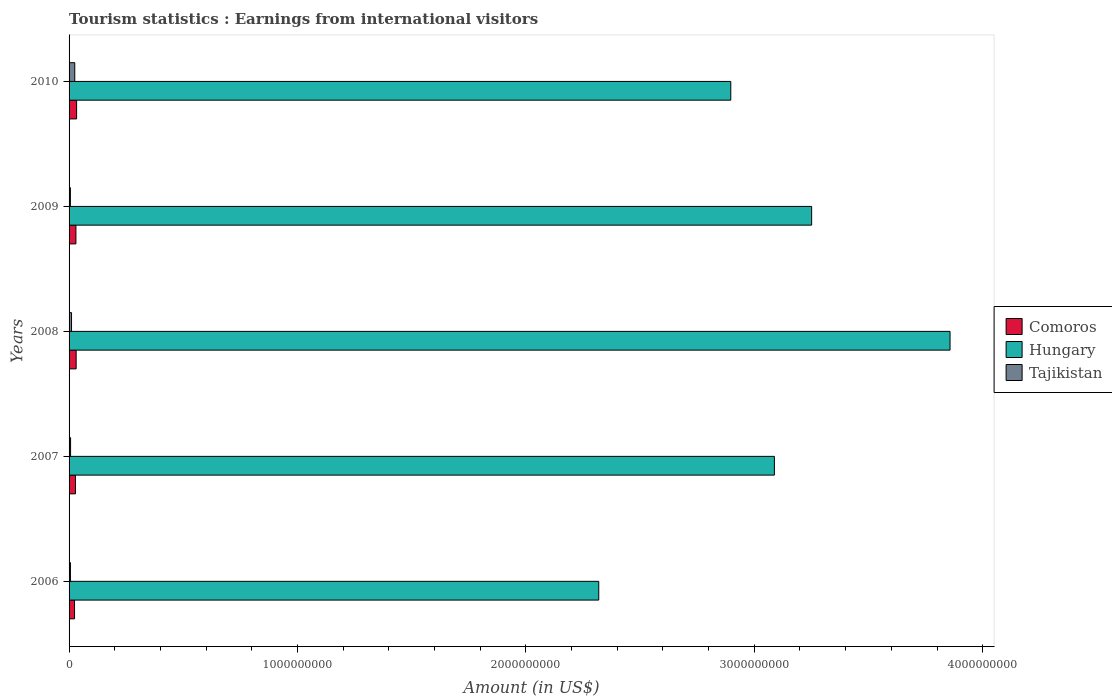How many groups of bars are there?
Your answer should be very brief. 5. Are the number of bars on each tick of the Y-axis equal?
Keep it short and to the point. Yes. How many bars are there on the 2nd tick from the top?
Make the answer very short. 3. How many bars are there on the 1st tick from the bottom?
Give a very brief answer. 3. What is the label of the 1st group of bars from the top?
Provide a succinct answer. 2010. What is the earnings from international visitors in Comoros in 2007?
Your response must be concise. 2.80e+07. Across all years, what is the maximum earnings from international visitors in Tajikistan?
Your answer should be very brief. 2.49e+07. Across all years, what is the minimum earnings from international visitors in Hungary?
Provide a succinct answer. 2.32e+09. In which year was the earnings from international visitors in Tajikistan maximum?
Offer a terse response. 2010. In which year was the earnings from international visitors in Tajikistan minimum?
Your answer should be very brief. 2009. What is the total earnings from international visitors in Hungary in the graph?
Keep it short and to the point. 1.54e+1. What is the difference between the earnings from international visitors in Hungary in 2009 and the earnings from international visitors in Tajikistan in 2007?
Your response must be concise. 3.24e+09. What is the average earnings from international visitors in Hungary per year?
Your response must be concise. 3.08e+09. In the year 2007, what is the difference between the earnings from international visitors in Comoros and earnings from international visitors in Hungary?
Offer a terse response. -3.06e+09. What is the ratio of the earnings from international visitors in Tajikistan in 2007 to that in 2008?
Ensure brevity in your answer.  0.61. Is the earnings from international visitors in Comoros in 2009 less than that in 2010?
Give a very brief answer. Yes. Is the difference between the earnings from international visitors in Comoros in 2008 and 2010 greater than the difference between the earnings from international visitors in Hungary in 2008 and 2010?
Ensure brevity in your answer.  No. What is the difference between the highest and the second highest earnings from international visitors in Comoros?
Your answer should be compact. 2.00e+06. What is the difference between the highest and the lowest earnings from international visitors in Hungary?
Give a very brief answer. 1.54e+09. What does the 3rd bar from the top in 2008 represents?
Offer a terse response. Comoros. What does the 2nd bar from the bottom in 2006 represents?
Provide a succinct answer. Hungary. Is it the case that in every year, the sum of the earnings from international visitors in Comoros and earnings from international visitors in Hungary is greater than the earnings from international visitors in Tajikistan?
Your answer should be very brief. Yes. How many years are there in the graph?
Give a very brief answer. 5. Are the values on the major ticks of X-axis written in scientific E-notation?
Give a very brief answer. No. Does the graph contain any zero values?
Your response must be concise. No. Does the graph contain grids?
Your response must be concise. No. How are the legend labels stacked?
Keep it short and to the point. Vertical. What is the title of the graph?
Offer a terse response. Tourism statistics : Earnings from international visitors. Does "High income" appear as one of the legend labels in the graph?
Ensure brevity in your answer.  No. What is the label or title of the X-axis?
Ensure brevity in your answer.  Amount (in US$). What is the label or title of the Y-axis?
Keep it short and to the point. Years. What is the Amount (in US$) in Comoros in 2006?
Give a very brief answer. 2.40e+07. What is the Amount (in US$) of Hungary in 2006?
Provide a succinct answer. 2.32e+09. What is the Amount (in US$) in Comoros in 2007?
Give a very brief answer. 2.80e+07. What is the Amount (in US$) of Hungary in 2007?
Make the answer very short. 3.09e+09. What is the Amount (in US$) of Tajikistan in 2007?
Offer a terse response. 6.57e+06. What is the Amount (in US$) of Comoros in 2008?
Make the answer very short. 3.10e+07. What is the Amount (in US$) of Hungary in 2008?
Your response must be concise. 3.86e+09. What is the Amount (in US$) in Tajikistan in 2008?
Provide a succinct answer. 1.08e+07. What is the Amount (in US$) of Comoros in 2009?
Ensure brevity in your answer.  3.00e+07. What is the Amount (in US$) in Hungary in 2009?
Provide a succinct answer. 3.25e+09. What is the Amount (in US$) in Tajikistan in 2009?
Give a very brief answer. 5.80e+06. What is the Amount (in US$) of Comoros in 2010?
Offer a terse response. 3.30e+07. What is the Amount (in US$) in Hungary in 2010?
Provide a short and direct response. 2.90e+09. What is the Amount (in US$) of Tajikistan in 2010?
Your response must be concise. 2.49e+07. Across all years, what is the maximum Amount (in US$) of Comoros?
Offer a very short reply. 3.30e+07. Across all years, what is the maximum Amount (in US$) in Hungary?
Make the answer very short. 3.86e+09. Across all years, what is the maximum Amount (in US$) in Tajikistan?
Offer a terse response. 2.49e+07. Across all years, what is the minimum Amount (in US$) of Comoros?
Offer a terse response. 2.40e+07. Across all years, what is the minimum Amount (in US$) in Hungary?
Your answer should be very brief. 2.32e+09. Across all years, what is the minimum Amount (in US$) of Tajikistan?
Provide a succinct answer. 5.80e+06. What is the total Amount (in US$) in Comoros in the graph?
Offer a terse response. 1.46e+08. What is the total Amount (in US$) of Hungary in the graph?
Your answer should be very brief. 1.54e+1. What is the total Amount (in US$) in Tajikistan in the graph?
Your response must be concise. 5.41e+07. What is the difference between the Amount (in US$) of Hungary in 2006 and that in 2007?
Your response must be concise. -7.69e+08. What is the difference between the Amount (in US$) of Tajikistan in 2006 and that in 2007?
Offer a very short reply. -5.70e+05. What is the difference between the Amount (in US$) in Comoros in 2006 and that in 2008?
Give a very brief answer. -7.00e+06. What is the difference between the Amount (in US$) in Hungary in 2006 and that in 2008?
Your answer should be very brief. -1.54e+09. What is the difference between the Amount (in US$) of Tajikistan in 2006 and that in 2008?
Keep it short and to the point. -4.80e+06. What is the difference between the Amount (in US$) of Comoros in 2006 and that in 2009?
Your response must be concise. -6.00e+06. What is the difference between the Amount (in US$) of Hungary in 2006 and that in 2009?
Your answer should be compact. -9.32e+08. What is the difference between the Amount (in US$) of Comoros in 2006 and that in 2010?
Your answer should be compact. -9.00e+06. What is the difference between the Amount (in US$) of Hungary in 2006 and that in 2010?
Your answer should be very brief. -5.78e+08. What is the difference between the Amount (in US$) in Tajikistan in 2006 and that in 2010?
Your response must be concise. -1.89e+07. What is the difference between the Amount (in US$) of Comoros in 2007 and that in 2008?
Offer a very short reply. -3.00e+06. What is the difference between the Amount (in US$) in Hungary in 2007 and that in 2008?
Provide a succinct answer. -7.69e+08. What is the difference between the Amount (in US$) of Tajikistan in 2007 and that in 2008?
Make the answer very short. -4.23e+06. What is the difference between the Amount (in US$) of Comoros in 2007 and that in 2009?
Make the answer very short. -2.00e+06. What is the difference between the Amount (in US$) in Hungary in 2007 and that in 2009?
Offer a very short reply. -1.63e+08. What is the difference between the Amount (in US$) in Tajikistan in 2007 and that in 2009?
Ensure brevity in your answer.  7.70e+05. What is the difference between the Amount (in US$) in Comoros in 2007 and that in 2010?
Your answer should be very brief. -5.00e+06. What is the difference between the Amount (in US$) of Hungary in 2007 and that in 2010?
Ensure brevity in your answer.  1.91e+08. What is the difference between the Amount (in US$) in Tajikistan in 2007 and that in 2010?
Make the answer very short. -1.83e+07. What is the difference between the Amount (in US$) in Comoros in 2008 and that in 2009?
Offer a very short reply. 1.00e+06. What is the difference between the Amount (in US$) of Hungary in 2008 and that in 2009?
Your answer should be compact. 6.06e+08. What is the difference between the Amount (in US$) of Comoros in 2008 and that in 2010?
Make the answer very short. -2.00e+06. What is the difference between the Amount (in US$) of Hungary in 2008 and that in 2010?
Your response must be concise. 9.60e+08. What is the difference between the Amount (in US$) of Tajikistan in 2008 and that in 2010?
Your answer should be compact. -1.41e+07. What is the difference between the Amount (in US$) of Hungary in 2009 and that in 2010?
Keep it short and to the point. 3.54e+08. What is the difference between the Amount (in US$) in Tajikistan in 2009 and that in 2010?
Your answer should be compact. -1.91e+07. What is the difference between the Amount (in US$) in Comoros in 2006 and the Amount (in US$) in Hungary in 2007?
Provide a short and direct response. -3.06e+09. What is the difference between the Amount (in US$) of Comoros in 2006 and the Amount (in US$) of Tajikistan in 2007?
Provide a short and direct response. 1.74e+07. What is the difference between the Amount (in US$) in Hungary in 2006 and the Amount (in US$) in Tajikistan in 2007?
Keep it short and to the point. 2.31e+09. What is the difference between the Amount (in US$) in Comoros in 2006 and the Amount (in US$) in Hungary in 2008?
Keep it short and to the point. -3.83e+09. What is the difference between the Amount (in US$) in Comoros in 2006 and the Amount (in US$) in Tajikistan in 2008?
Keep it short and to the point. 1.32e+07. What is the difference between the Amount (in US$) in Hungary in 2006 and the Amount (in US$) in Tajikistan in 2008?
Keep it short and to the point. 2.31e+09. What is the difference between the Amount (in US$) of Comoros in 2006 and the Amount (in US$) of Hungary in 2009?
Your answer should be very brief. -3.23e+09. What is the difference between the Amount (in US$) in Comoros in 2006 and the Amount (in US$) in Tajikistan in 2009?
Give a very brief answer. 1.82e+07. What is the difference between the Amount (in US$) of Hungary in 2006 and the Amount (in US$) of Tajikistan in 2009?
Offer a very short reply. 2.31e+09. What is the difference between the Amount (in US$) in Comoros in 2006 and the Amount (in US$) in Hungary in 2010?
Provide a succinct answer. -2.87e+09. What is the difference between the Amount (in US$) of Comoros in 2006 and the Amount (in US$) of Tajikistan in 2010?
Provide a short and direct response. -9.00e+05. What is the difference between the Amount (in US$) of Hungary in 2006 and the Amount (in US$) of Tajikistan in 2010?
Ensure brevity in your answer.  2.29e+09. What is the difference between the Amount (in US$) of Comoros in 2007 and the Amount (in US$) of Hungary in 2008?
Provide a succinct answer. -3.83e+09. What is the difference between the Amount (in US$) of Comoros in 2007 and the Amount (in US$) of Tajikistan in 2008?
Provide a short and direct response. 1.72e+07. What is the difference between the Amount (in US$) in Hungary in 2007 and the Amount (in US$) in Tajikistan in 2008?
Your answer should be compact. 3.08e+09. What is the difference between the Amount (in US$) in Comoros in 2007 and the Amount (in US$) in Hungary in 2009?
Your answer should be compact. -3.22e+09. What is the difference between the Amount (in US$) of Comoros in 2007 and the Amount (in US$) of Tajikistan in 2009?
Ensure brevity in your answer.  2.22e+07. What is the difference between the Amount (in US$) of Hungary in 2007 and the Amount (in US$) of Tajikistan in 2009?
Make the answer very short. 3.08e+09. What is the difference between the Amount (in US$) of Comoros in 2007 and the Amount (in US$) of Hungary in 2010?
Your response must be concise. -2.87e+09. What is the difference between the Amount (in US$) in Comoros in 2007 and the Amount (in US$) in Tajikistan in 2010?
Ensure brevity in your answer.  3.10e+06. What is the difference between the Amount (in US$) in Hungary in 2007 and the Amount (in US$) in Tajikistan in 2010?
Give a very brief answer. 3.06e+09. What is the difference between the Amount (in US$) in Comoros in 2008 and the Amount (in US$) in Hungary in 2009?
Your answer should be very brief. -3.22e+09. What is the difference between the Amount (in US$) in Comoros in 2008 and the Amount (in US$) in Tajikistan in 2009?
Offer a terse response. 2.52e+07. What is the difference between the Amount (in US$) of Hungary in 2008 and the Amount (in US$) of Tajikistan in 2009?
Your answer should be compact. 3.85e+09. What is the difference between the Amount (in US$) in Comoros in 2008 and the Amount (in US$) in Hungary in 2010?
Provide a succinct answer. -2.87e+09. What is the difference between the Amount (in US$) in Comoros in 2008 and the Amount (in US$) in Tajikistan in 2010?
Offer a terse response. 6.10e+06. What is the difference between the Amount (in US$) of Hungary in 2008 and the Amount (in US$) of Tajikistan in 2010?
Provide a short and direct response. 3.83e+09. What is the difference between the Amount (in US$) in Comoros in 2009 and the Amount (in US$) in Hungary in 2010?
Your answer should be compact. -2.87e+09. What is the difference between the Amount (in US$) in Comoros in 2009 and the Amount (in US$) in Tajikistan in 2010?
Keep it short and to the point. 5.10e+06. What is the difference between the Amount (in US$) of Hungary in 2009 and the Amount (in US$) of Tajikistan in 2010?
Your response must be concise. 3.23e+09. What is the average Amount (in US$) of Comoros per year?
Your answer should be very brief. 2.92e+07. What is the average Amount (in US$) of Hungary per year?
Make the answer very short. 3.08e+09. What is the average Amount (in US$) in Tajikistan per year?
Your answer should be very brief. 1.08e+07. In the year 2006, what is the difference between the Amount (in US$) of Comoros and Amount (in US$) of Hungary?
Make the answer very short. -2.30e+09. In the year 2006, what is the difference between the Amount (in US$) in Comoros and Amount (in US$) in Tajikistan?
Offer a terse response. 1.80e+07. In the year 2006, what is the difference between the Amount (in US$) of Hungary and Amount (in US$) of Tajikistan?
Make the answer very short. 2.31e+09. In the year 2007, what is the difference between the Amount (in US$) in Comoros and Amount (in US$) in Hungary?
Your response must be concise. -3.06e+09. In the year 2007, what is the difference between the Amount (in US$) in Comoros and Amount (in US$) in Tajikistan?
Provide a short and direct response. 2.14e+07. In the year 2007, what is the difference between the Amount (in US$) in Hungary and Amount (in US$) in Tajikistan?
Your answer should be very brief. 3.08e+09. In the year 2008, what is the difference between the Amount (in US$) in Comoros and Amount (in US$) in Hungary?
Provide a short and direct response. -3.83e+09. In the year 2008, what is the difference between the Amount (in US$) of Comoros and Amount (in US$) of Tajikistan?
Give a very brief answer. 2.02e+07. In the year 2008, what is the difference between the Amount (in US$) of Hungary and Amount (in US$) of Tajikistan?
Offer a terse response. 3.85e+09. In the year 2009, what is the difference between the Amount (in US$) of Comoros and Amount (in US$) of Hungary?
Your answer should be very brief. -3.22e+09. In the year 2009, what is the difference between the Amount (in US$) in Comoros and Amount (in US$) in Tajikistan?
Your answer should be very brief. 2.42e+07. In the year 2009, what is the difference between the Amount (in US$) in Hungary and Amount (in US$) in Tajikistan?
Provide a succinct answer. 3.25e+09. In the year 2010, what is the difference between the Amount (in US$) in Comoros and Amount (in US$) in Hungary?
Ensure brevity in your answer.  -2.86e+09. In the year 2010, what is the difference between the Amount (in US$) in Comoros and Amount (in US$) in Tajikistan?
Your answer should be very brief. 8.10e+06. In the year 2010, what is the difference between the Amount (in US$) in Hungary and Amount (in US$) in Tajikistan?
Offer a very short reply. 2.87e+09. What is the ratio of the Amount (in US$) in Comoros in 2006 to that in 2007?
Provide a short and direct response. 0.86. What is the ratio of the Amount (in US$) of Hungary in 2006 to that in 2007?
Give a very brief answer. 0.75. What is the ratio of the Amount (in US$) in Tajikistan in 2006 to that in 2007?
Ensure brevity in your answer.  0.91. What is the ratio of the Amount (in US$) in Comoros in 2006 to that in 2008?
Give a very brief answer. 0.77. What is the ratio of the Amount (in US$) in Hungary in 2006 to that in 2008?
Your response must be concise. 0.6. What is the ratio of the Amount (in US$) of Tajikistan in 2006 to that in 2008?
Offer a terse response. 0.56. What is the ratio of the Amount (in US$) of Comoros in 2006 to that in 2009?
Provide a succinct answer. 0.8. What is the ratio of the Amount (in US$) in Hungary in 2006 to that in 2009?
Give a very brief answer. 0.71. What is the ratio of the Amount (in US$) in Tajikistan in 2006 to that in 2009?
Ensure brevity in your answer.  1.03. What is the ratio of the Amount (in US$) in Comoros in 2006 to that in 2010?
Ensure brevity in your answer.  0.73. What is the ratio of the Amount (in US$) of Hungary in 2006 to that in 2010?
Your answer should be very brief. 0.8. What is the ratio of the Amount (in US$) of Tajikistan in 2006 to that in 2010?
Offer a terse response. 0.24. What is the ratio of the Amount (in US$) of Comoros in 2007 to that in 2008?
Provide a succinct answer. 0.9. What is the ratio of the Amount (in US$) of Hungary in 2007 to that in 2008?
Offer a terse response. 0.8. What is the ratio of the Amount (in US$) in Tajikistan in 2007 to that in 2008?
Your response must be concise. 0.61. What is the ratio of the Amount (in US$) of Hungary in 2007 to that in 2009?
Offer a very short reply. 0.95. What is the ratio of the Amount (in US$) in Tajikistan in 2007 to that in 2009?
Offer a very short reply. 1.13. What is the ratio of the Amount (in US$) of Comoros in 2007 to that in 2010?
Ensure brevity in your answer.  0.85. What is the ratio of the Amount (in US$) in Hungary in 2007 to that in 2010?
Your answer should be very brief. 1.07. What is the ratio of the Amount (in US$) of Tajikistan in 2007 to that in 2010?
Provide a succinct answer. 0.26. What is the ratio of the Amount (in US$) in Comoros in 2008 to that in 2009?
Your answer should be compact. 1.03. What is the ratio of the Amount (in US$) of Hungary in 2008 to that in 2009?
Make the answer very short. 1.19. What is the ratio of the Amount (in US$) of Tajikistan in 2008 to that in 2009?
Keep it short and to the point. 1.86. What is the ratio of the Amount (in US$) in Comoros in 2008 to that in 2010?
Your answer should be very brief. 0.94. What is the ratio of the Amount (in US$) in Hungary in 2008 to that in 2010?
Provide a succinct answer. 1.33. What is the ratio of the Amount (in US$) in Tajikistan in 2008 to that in 2010?
Your answer should be very brief. 0.43. What is the ratio of the Amount (in US$) of Comoros in 2009 to that in 2010?
Offer a very short reply. 0.91. What is the ratio of the Amount (in US$) in Hungary in 2009 to that in 2010?
Give a very brief answer. 1.12. What is the ratio of the Amount (in US$) of Tajikistan in 2009 to that in 2010?
Ensure brevity in your answer.  0.23. What is the difference between the highest and the second highest Amount (in US$) in Hungary?
Offer a terse response. 6.06e+08. What is the difference between the highest and the second highest Amount (in US$) of Tajikistan?
Offer a very short reply. 1.41e+07. What is the difference between the highest and the lowest Amount (in US$) in Comoros?
Ensure brevity in your answer.  9.00e+06. What is the difference between the highest and the lowest Amount (in US$) of Hungary?
Make the answer very short. 1.54e+09. What is the difference between the highest and the lowest Amount (in US$) of Tajikistan?
Provide a short and direct response. 1.91e+07. 